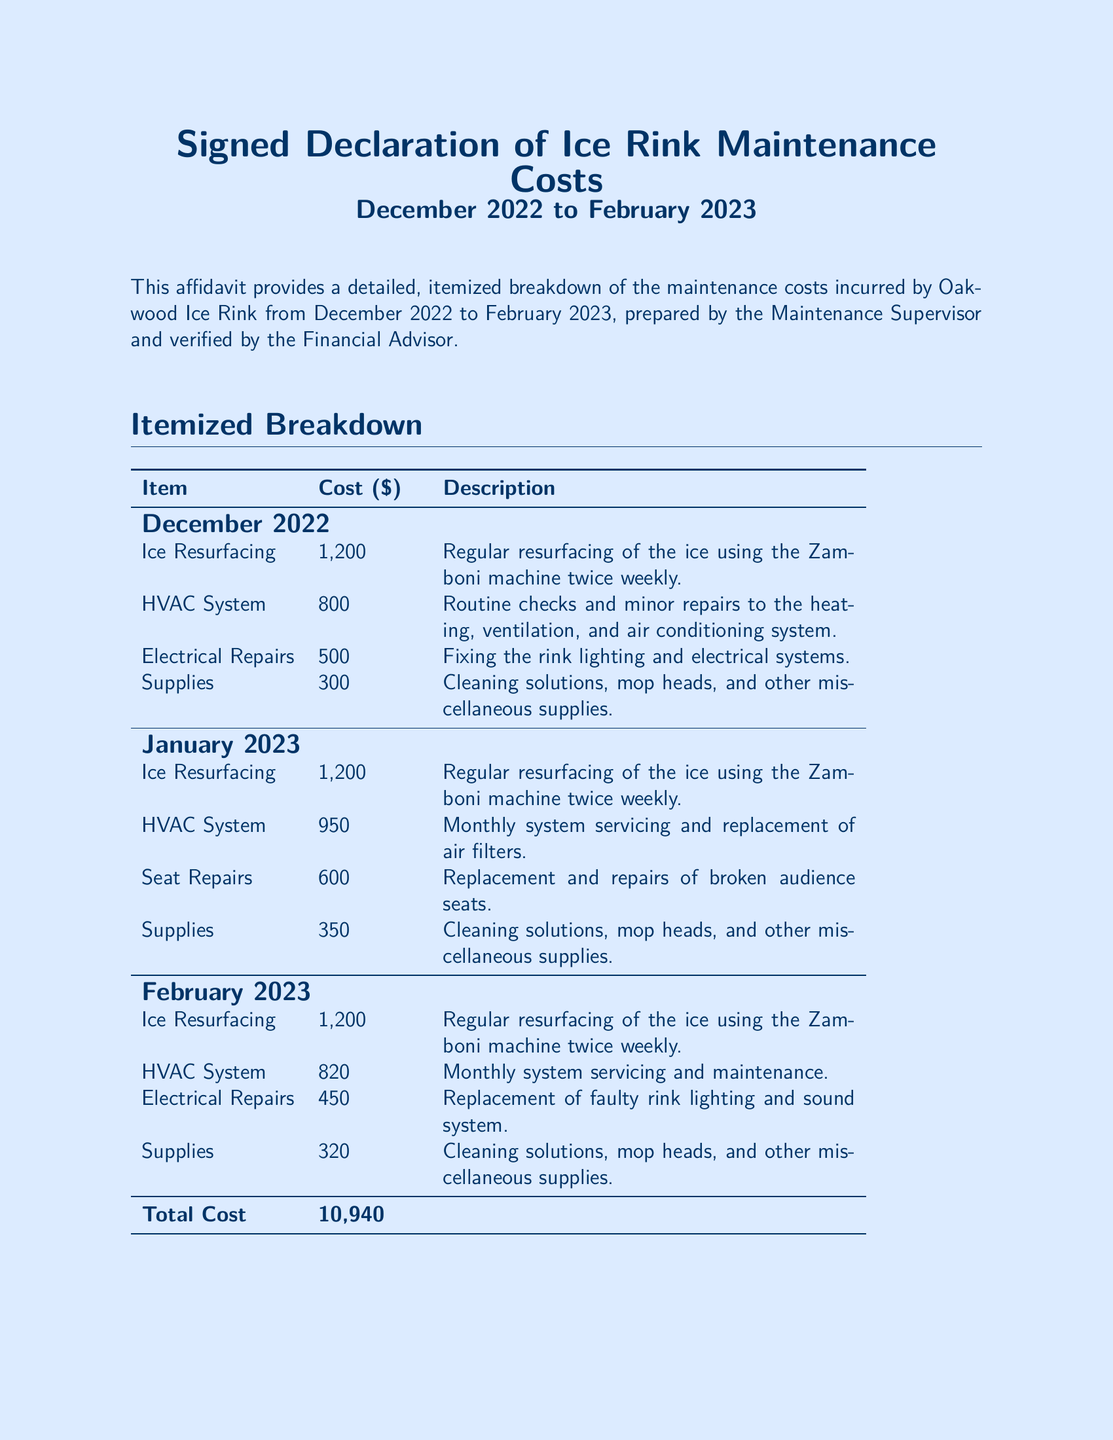what is the total maintenance cost? The total maintenance cost is the cumulative sum of all costs listed in the document, which is $10,940.
Answer: $10,940 who prepared the maintenance cost document? The document was prepared by John Davis, the Ice Rink Manager.
Answer: John Davis which month had the highest HVAC system costs? By comparing the HVAC system costs across the months, January 2023 had the highest cost at $950.
Answer: January 2023 what is the cost of electrical repairs in February 2023? The cost listed for electrical repairs in February 2023 is $450.
Answer: $450 how many times per week is ice resurfacing done? The document states that ice resurfacing is performed twice weekly.
Answer: twice weekly who verified the maintenance costs? The verification of the maintenance costs was done by Mrs. Amelia Carter, the Math Teacher and Financial Advisor.
Answer: Mrs. Amelia Carter in what format is the itemized breakdown presented? The itemized breakdown is presented in a tabular format listing items, costs, and descriptions.
Answer: tabular format what date was the affidavit signed? The affidavit was signed on March 12, 2023.
Answer: March 12, 2023 which month had costs associated with seat repairs? The month listed with costs for seat repairs is January 2023.
Answer: January 2023 